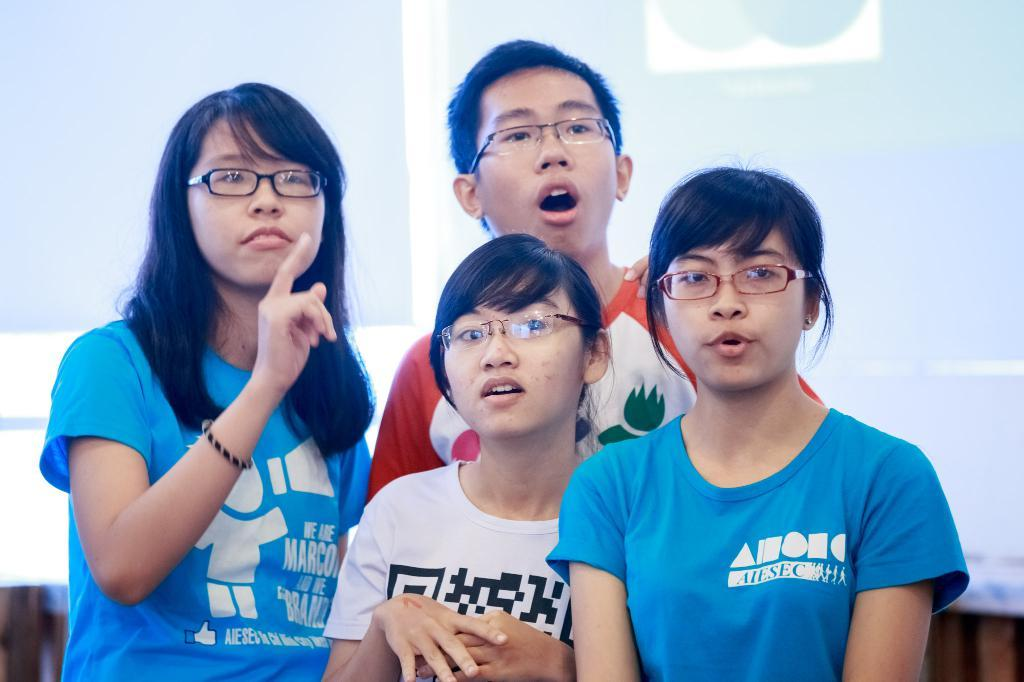What can be seen in the foreground of the picture? There are people standing in the foreground of the picture. How would you describe the background of the image? The background of the image is blurred. What is present in the background of the image? There is a banner in the background of the image. Can you tell me how many tanks are visible in the image? There are no tanks present in the image. What type of zebra can be seen interacting with the banner in the image? There is no zebra present in the image; only people and a banner are visible. 